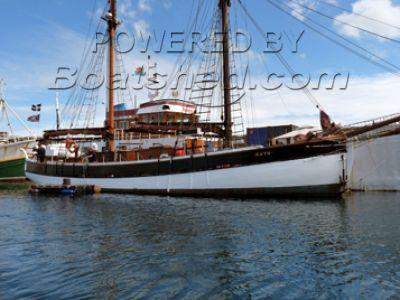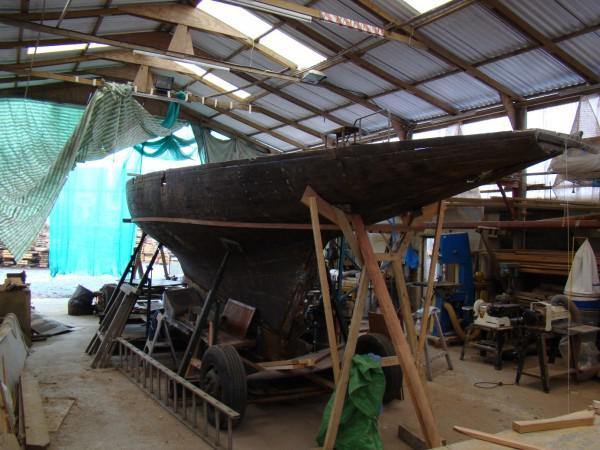The first image is the image on the left, the second image is the image on the right. Assess this claim about the two images: "The left and right image contains the same number of sailboats.". Correct or not? Answer yes or no. Yes. The first image is the image on the left, the second image is the image on the right. Evaluate the accuracy of this statement regarding the images: "A boat in the right image is out of the water.". Is it true? Answer yes or no. Yes. 